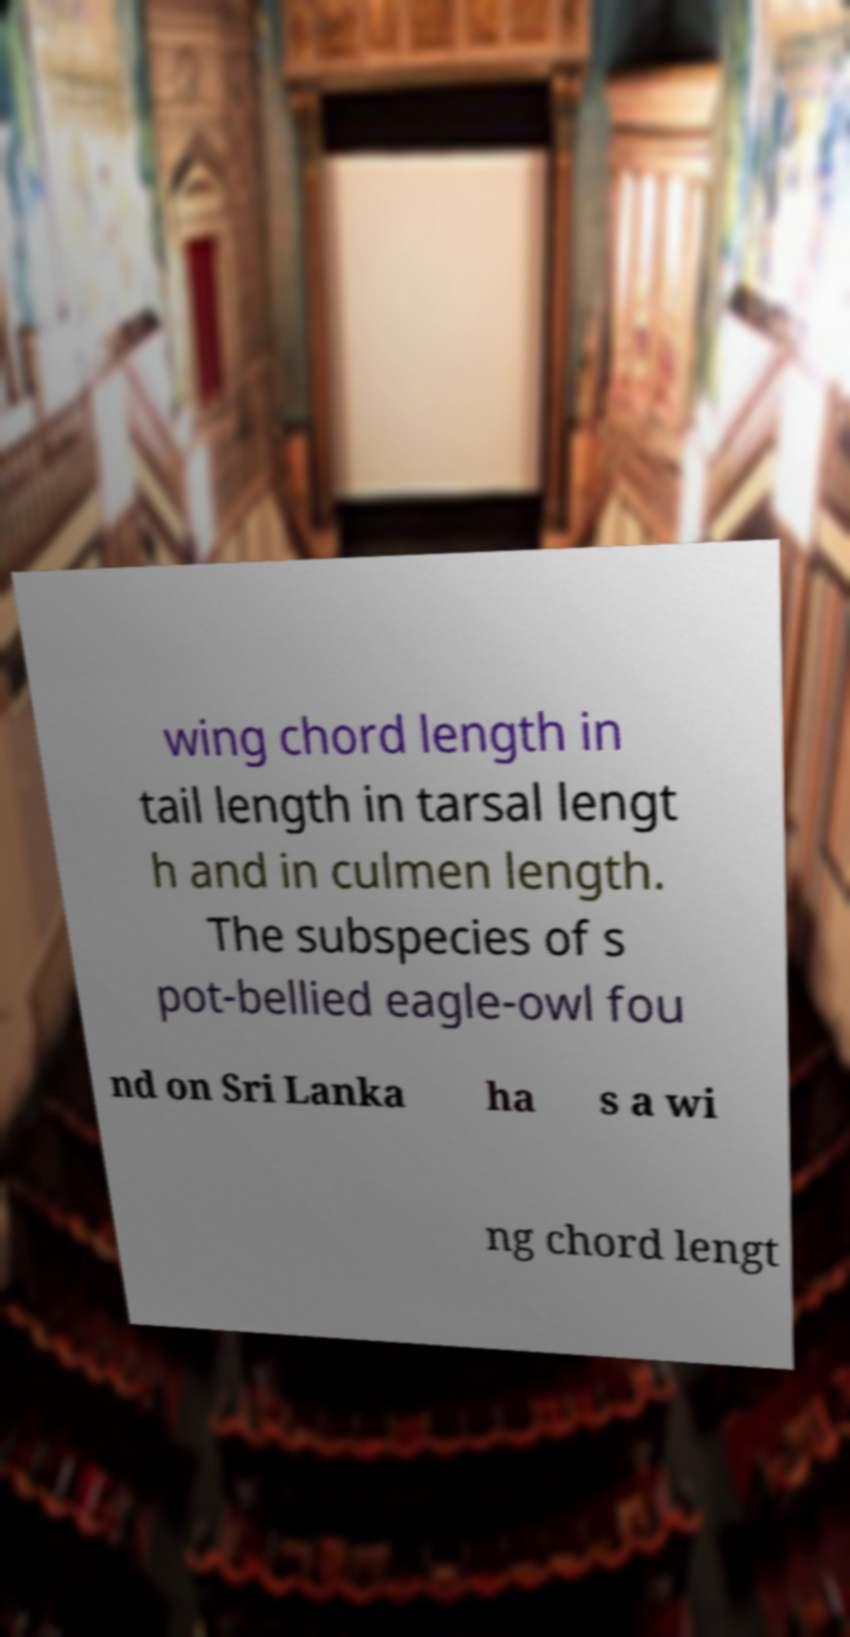Can you read and provide the text displayed in the image?This photo seems to have some interesting text. Can you extract and type it out for me? wing chord length in tail length in tarsal lengt h and in culmen length. The subspecies of s pot-bellied eagle-owl fou nd on Sri Lanka ha s a wi ng chord lengt 